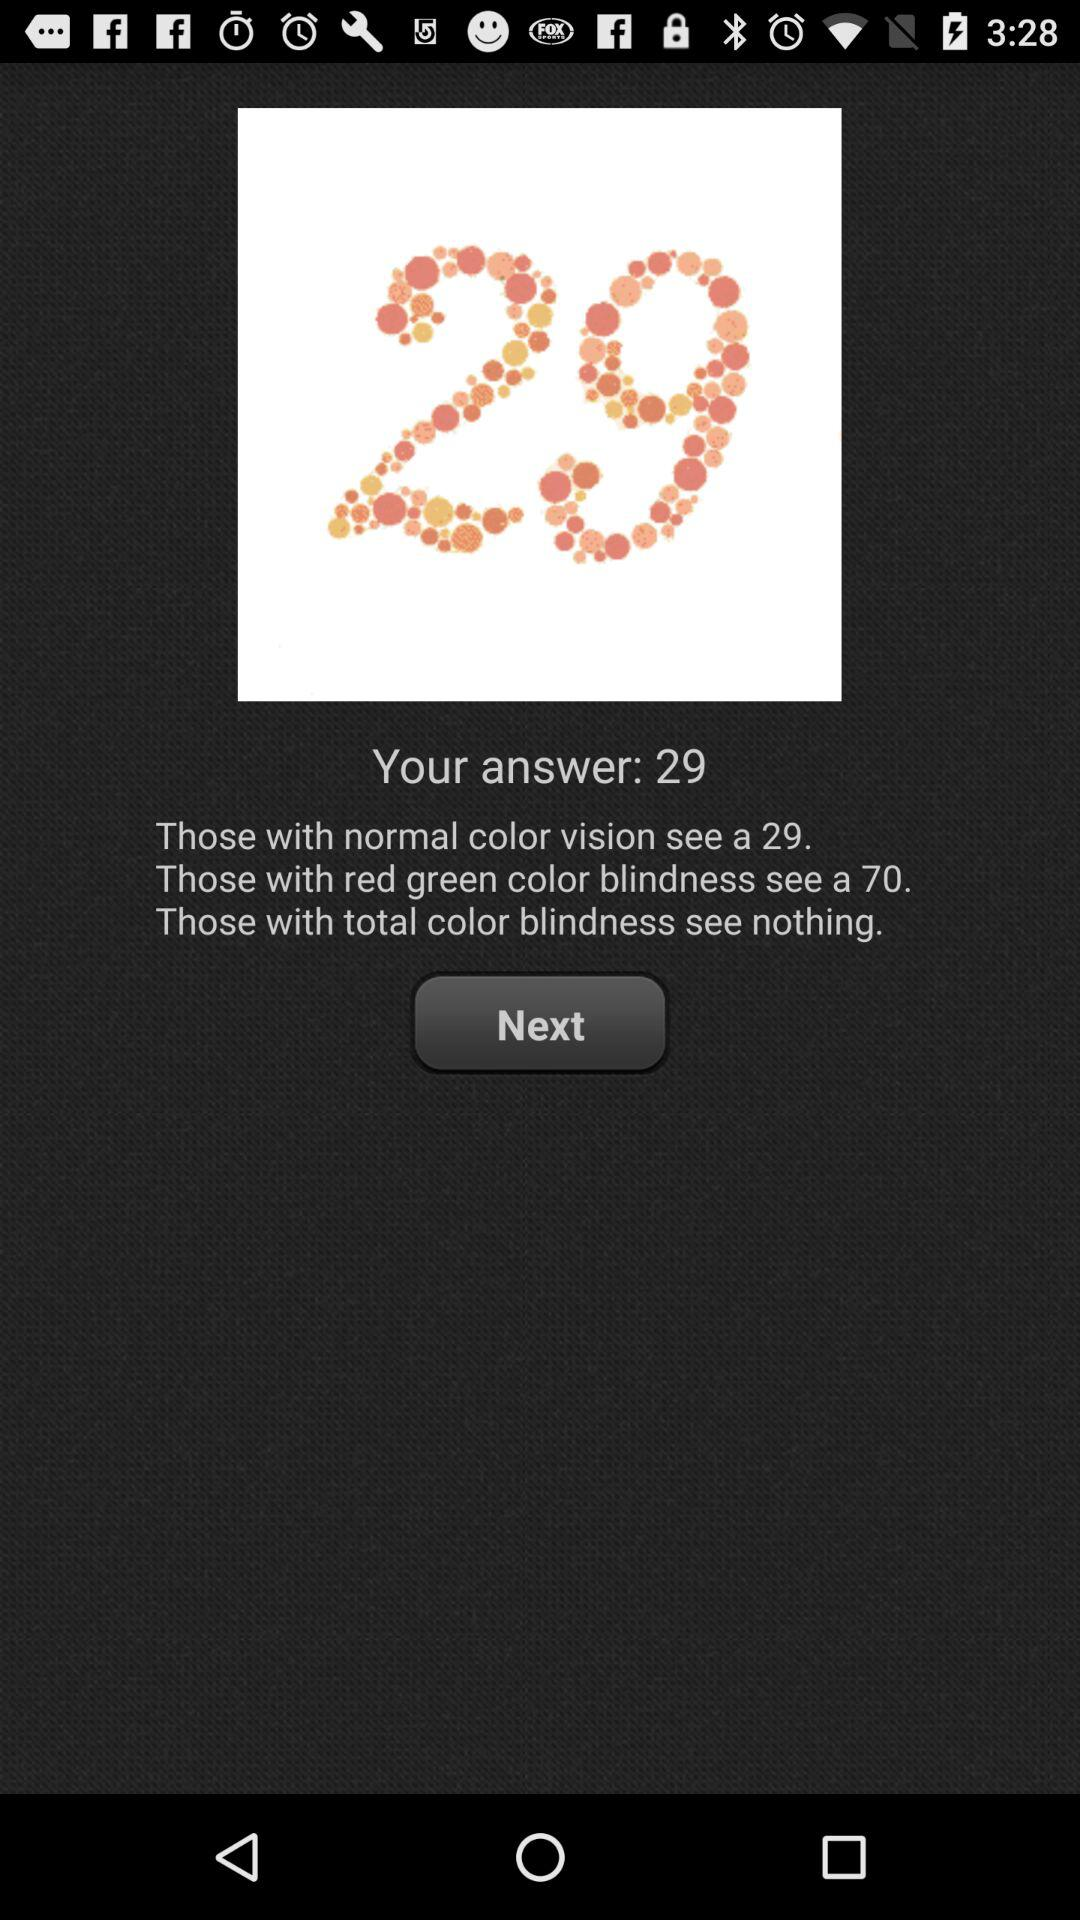What can people with total color blindness see? People with total color blindness can see "nothing". 